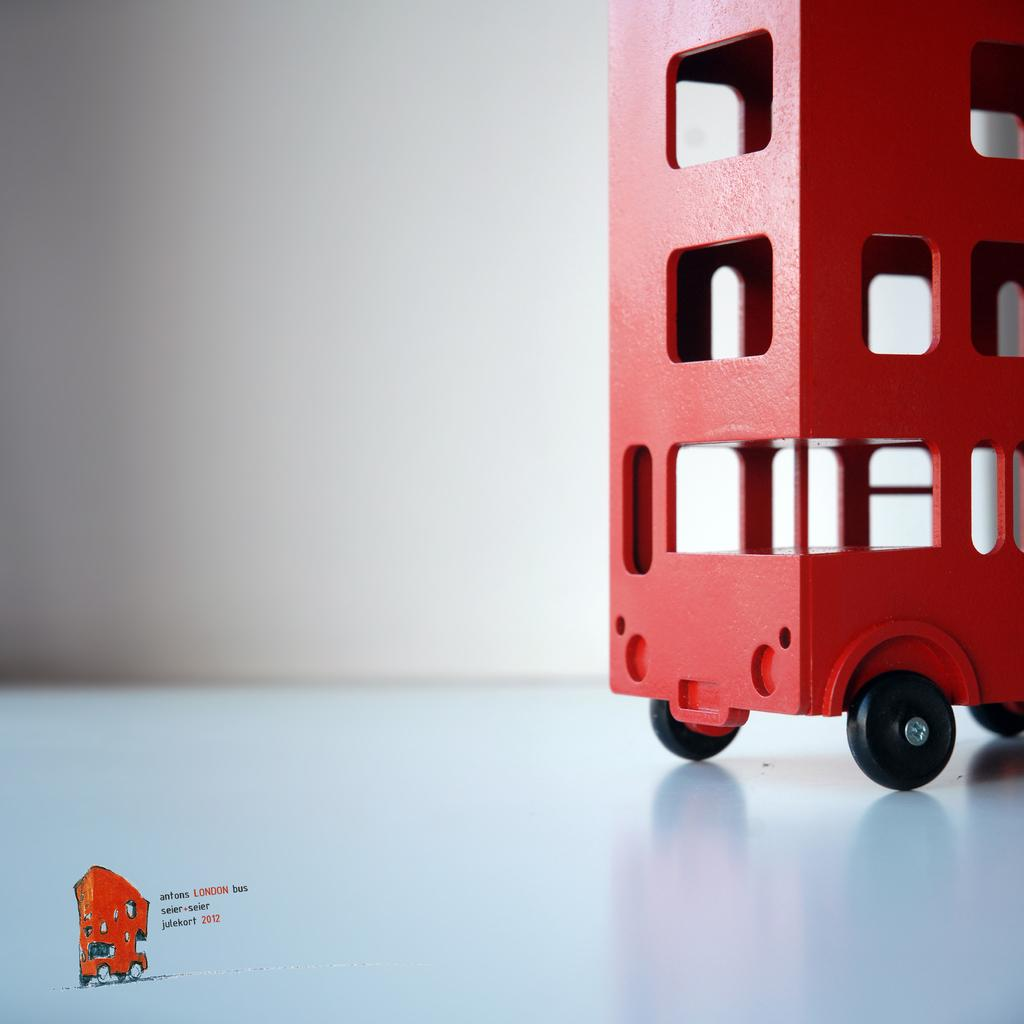What object is the main subject of the image? There is a toy vehicle in the image. Where is the toy vehicle located? The toy vehicle is placed on a table. What can be seen in the background of the image? There is a wall in the background of the image. What type of drum is being played in the image? There is no drum present in the image; it features a toy vehicle placed on a table. How can the order of the toy vehicle be improved in the image? The image does not depict an order or arrangement of the toy vehicle, as it is simply placed on a table. 